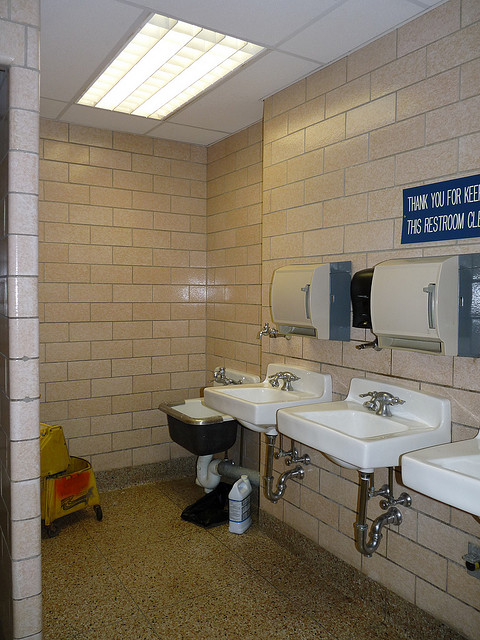How is the cleanliness standard of this restroom maintained? Maintenance of cleanliness in this restroom is likely managed through routine cleaning schedules, evidenced by the presence of cleaning chemicals and equipment. 